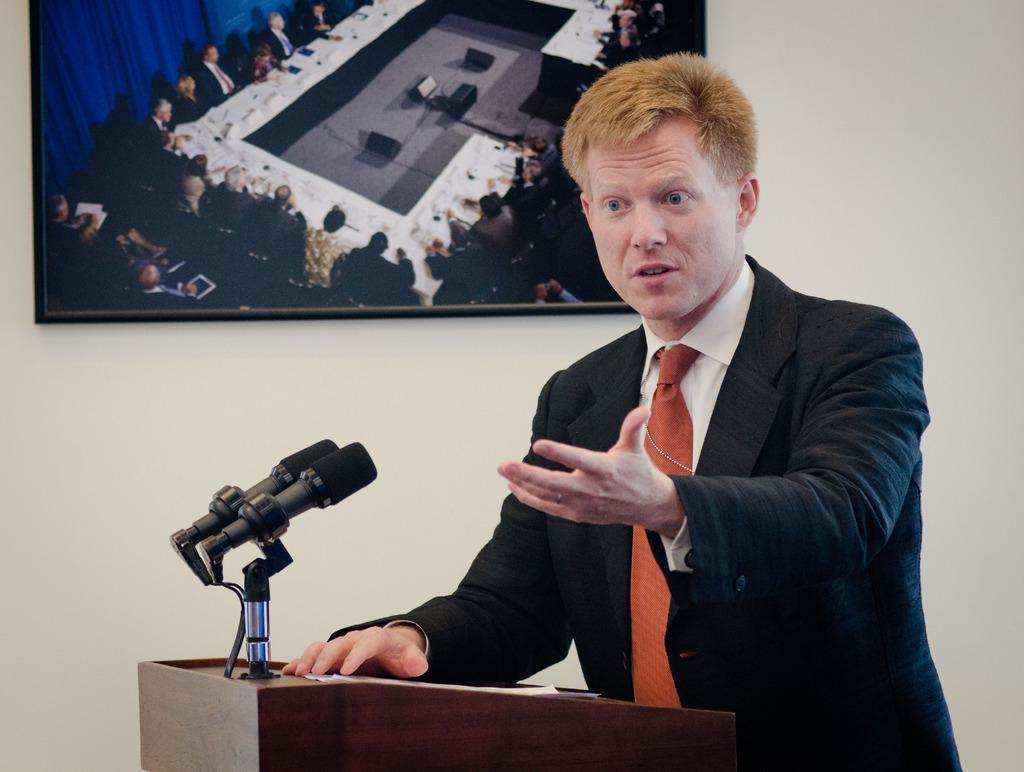Who is the main subject in the image? There is a man in the image. What objects are in front of the man? There are microphones and a podium in front of the man. What can be seen on the wall behind the man? There is a frame on the wall behind the man. Is there a feast happening in the image? There is no indication of a feast in the image; it features a man with microphones and a podium in front of him. Can you see any ghosts in the image? There are no ghosts present in the image. 